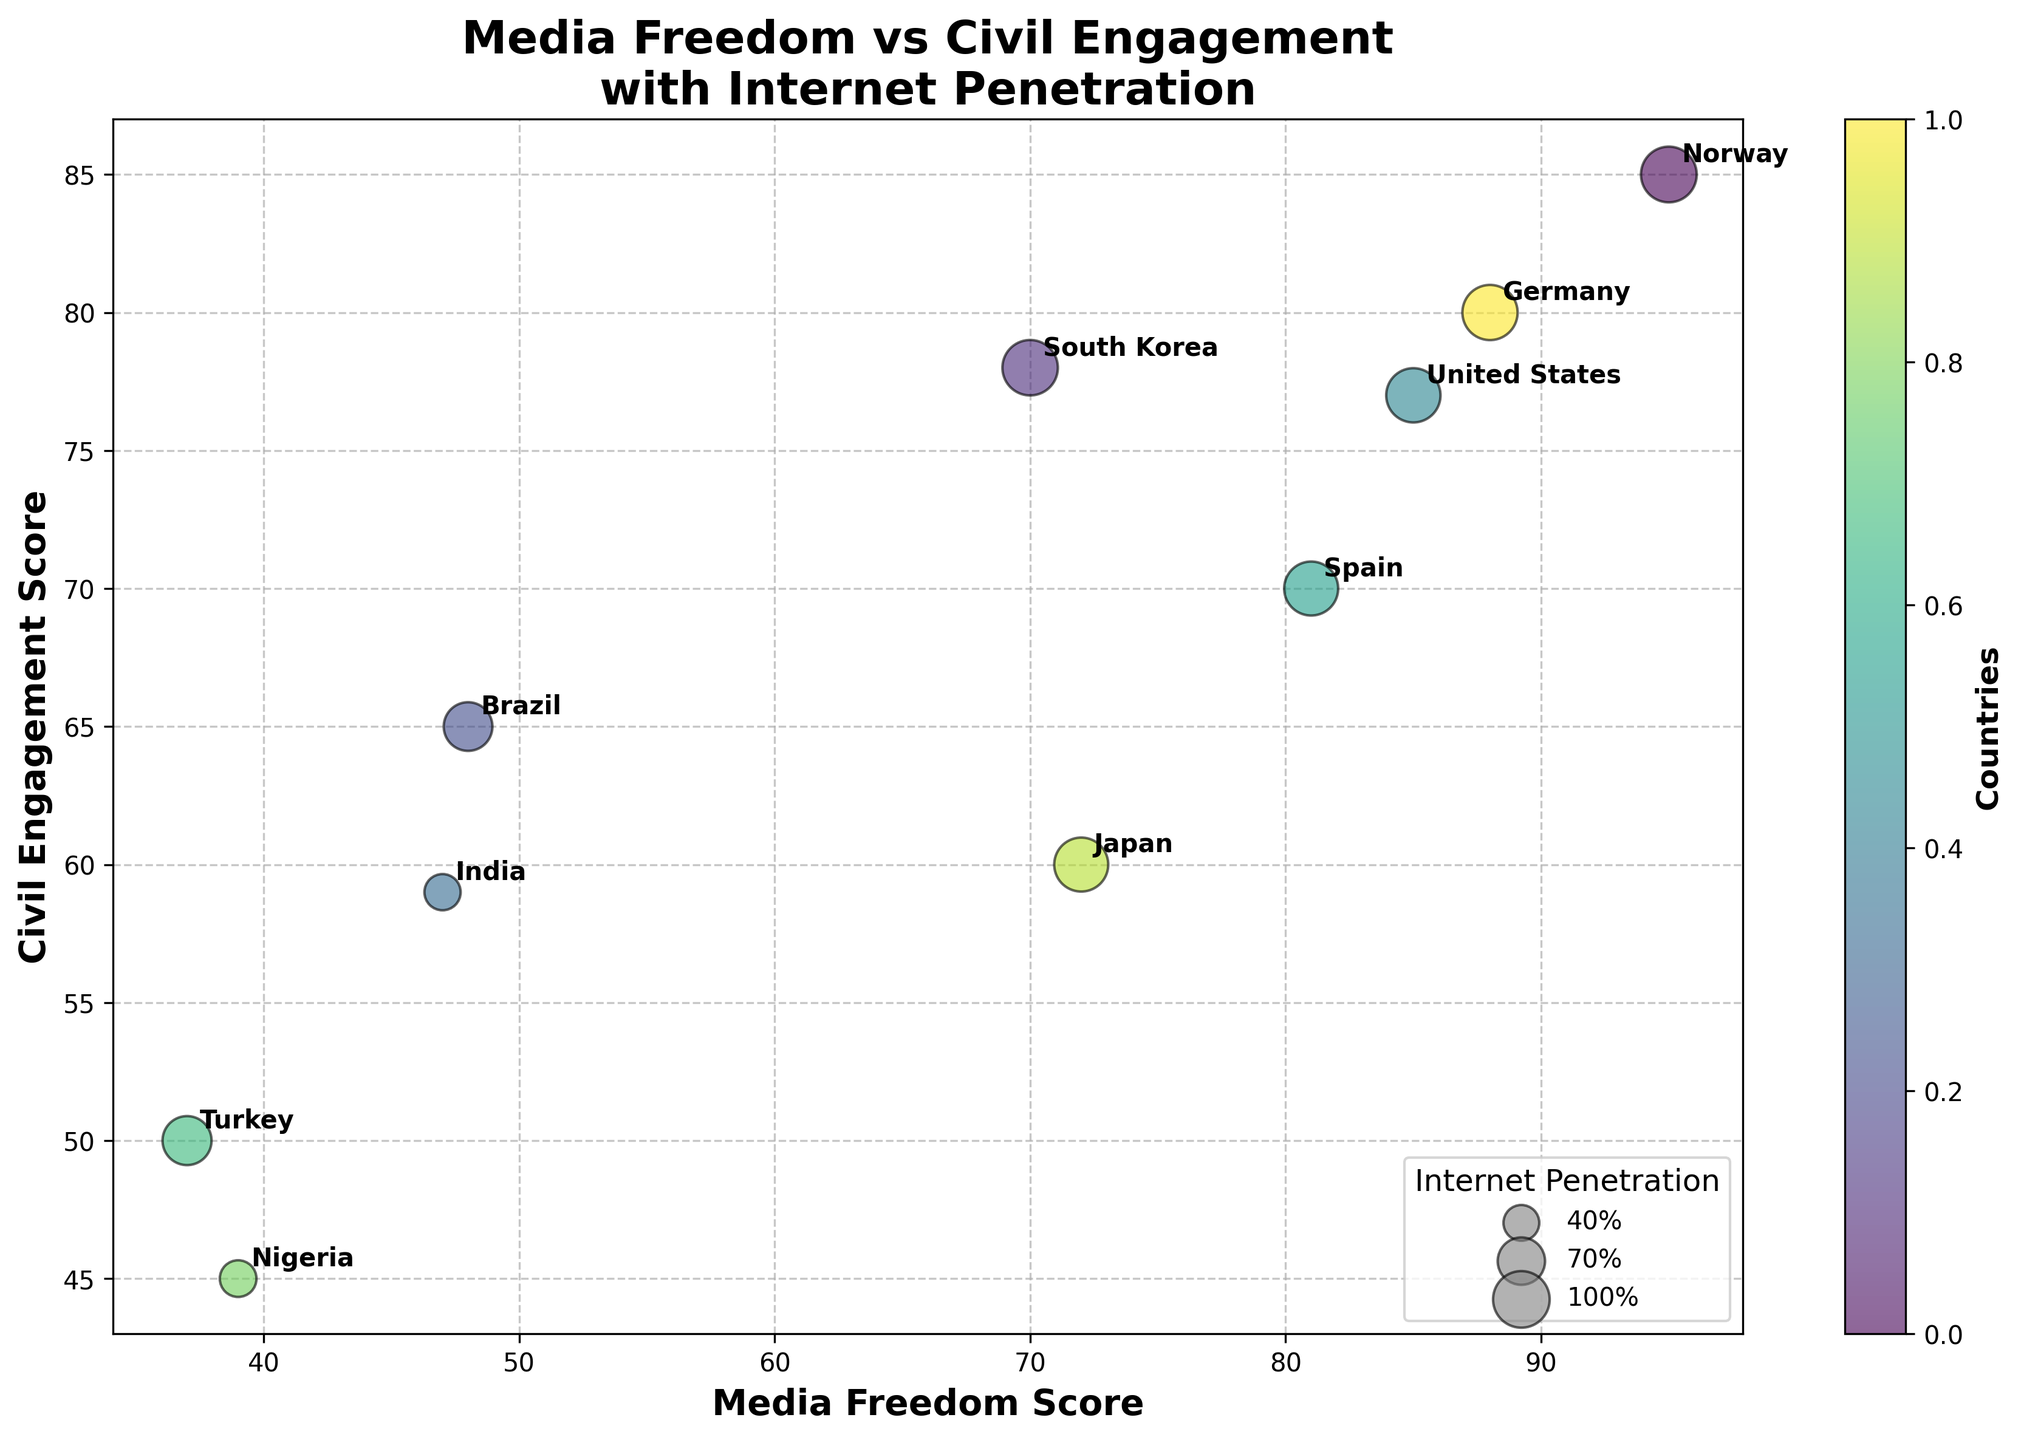What is the title of the figure? The title of the figure is found at the top of the plot. It reads "Media Freedom vs Civil Engagement with Internet Penetration."
Answer: Media Freedom vs Civil Engagement with Internet Penetration Which country has the highest media freedom score? The media freedom score is represented on the x-axis. The country farthest to the right on this axis is Norway, which has a media freedom score of 95.
Answer: Norway What size represent bubbles with 97% internet penetration? The legend in the lower right corner of the plot shows bubble sizes corresponding to different percentages of internet penetration. The largest bubble in the legend is labeled as '97%.'
Answer: 97% Which country appears to have the largest population? The bubbles are proportional in size to the country's population, with larger bubbles indicating larger populations. The largest bubble belongs to India.
Answer: India How many countries have a civil engagement score above 75? The y-axis represents the civil engagement score. Count the bubbles that fall above the 75 mark on the y-axis. These countries are Norway and South Korea (only two countries).
Answer: 2 Which country has the lowest civil engagement score, and what is that score? Look for the bubble positioned lowest on the y-axis. This bubble corresponds to Nigeria, which has a civil engagement score of 45.
Answer: Nigeria, 45 Which country has almost the same internet penetration rate but different civil engagement scores? Compare the sizes of the bubbles to identify similar internet penetration rates, then look at their positions on the y-axis for variations in civil engagement scores. For example, South Korea and Brazil have nearly similar bubble sizes, but South Korea has a significantly higher civil engagement score.
Answer: South Korea and Brazil Which countries have internet penetration rates greater than 90%? Compare bubble sizes relative to the legend. The countries with larger bubbles representing over 90% internet penetration include Norway, South Korea, United States, Spain, and Japan.
Answer: Norway, South Korea, United States, Spain, Japan What's the average of the media freedom scores for countries with civil engagement scores higher than 75? First, identify the countries with civil engagement scores above 75: Norway, South Korea, United States, and Germany. Their media freedom scores are 95, 70, 85, and 88. The average is calculated as (95 + 70 + 85 + 88) / 4 = 84.5
Answer: 84.5 